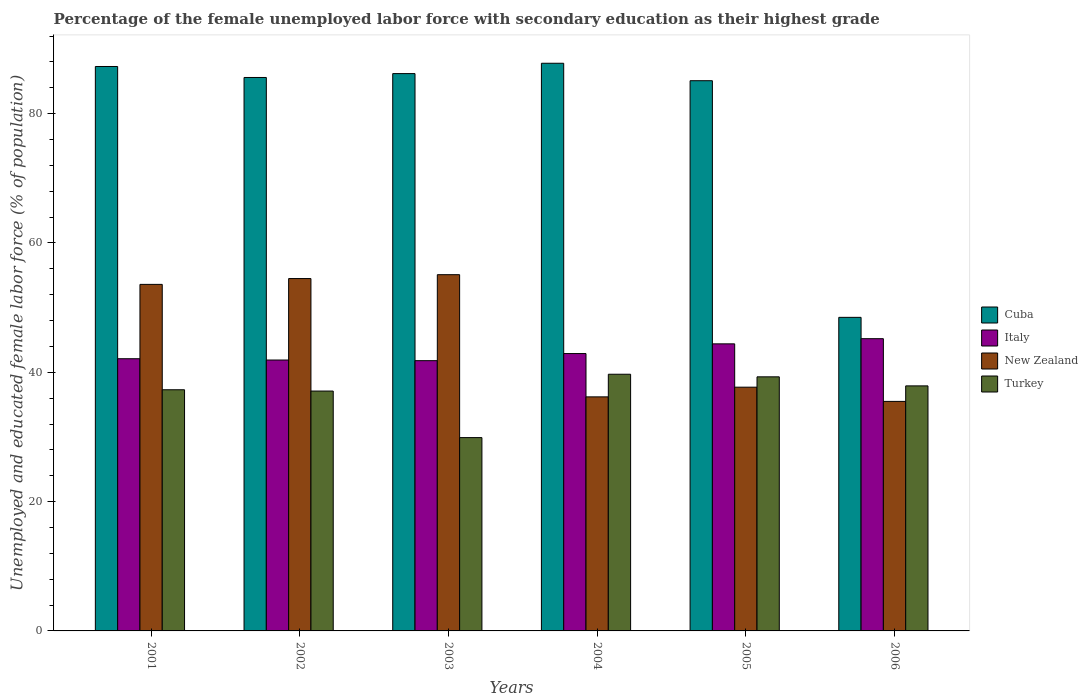How many different coloured bars are there?
Provide a short and direct response. 4. How many groups of bars are there?
Offer a very short reply. 6. Are the number of bars per tick equal to the number of legend labels?
Offer a terse response. Yes. What is the percentage of the unemployed female labor force with secondary education in New Zealand in 2005?
Offer a terse response. 37.7. Across all years, what is the maximum percentage of the unemployed female labor force with secondary education in Italy?
Give a very brief answer. 45.2. Across all years, what is the minimum percentage of the unemployed female labor force with secondary education in Turkey?
Your answer should be very brief. 29.9. In which year was the percentage of the unemployed female labor force with secondary education in Turkey minimum?
Make the answer very short. 2003. What is the total percentage of the unemployed female labor force with secondary education in Italy in the graph?
Offer a very short reply. 258.3. What is the difference between the percentage of the unemployed female labor force with secondary education in New Zealand in 2002 and that in 2004?
Offer a very short reply. 18.3. What is the difference between the percentage of the unemployed female labor force with secondary education in Italy in 2005 and the percentage of the unemployed female labor force with secondary education in Turkey in 2004?
Your response must be concise. 4.7. What is the average percentage of the unemployed female labor force with secondary education in Turkey per year?
Offer a terse response. 36.87. In the year 2004, what is the difference between the percentage of the unemployed female labor force with secondary education in Cuba and percentage of the unemployed female labor force with secondary education in Italy?
Provide a succinct answer. 44.9. What is the ratio of the percentage of the unemployed female labor force with secondary education in Turkey in 2001 to that in 2002?
Your response must be concise. 1.01. Is the percentage of the unemployed female labor force with secondary education in New Zealand in 2002 less than that in 2003?
Give a very brief answer. Yes. Is the difference between the percentage of the unemployed female labor force with secondary education in Cuba in 2002 and 2005 greater than the difference between the percentage of the unemployed female labor force with secondary education in Italy in 2002 and 2005?
Your answer should be very brief. Yes. What is the difference between the highest and the second highest percentage of the unemployed female labor force with secondary education in New Zealand?
Your answer should be compact. 0.6. What is the difference between the highest and the lowest percentage of the unemployed female labor force with secondary education in Cuba?
Provide a short and direct response. 39.3. In how many years, is the percentage of the unemployed female labor force with secondary education in New Zealand greater than the average percentage of the unemployed female labor force with secondary education in New Zealand taken over all years?
Your answer should be very brief. 3. What does the 1st bar from the right in 2006 represents?
Your answer should be very brief. Turkey. How many bars are there?
Make the answer very short. 24. Are all the bars in the graph horizontal?
Make the answer very short. No. Are the values on the major ticks of Y-axis written in scientific E-notation?
Offer a terse response. No. Does the graph contain any zero values?
Make the answer very short. No. Does the graph contain grids?
Your answer should be compact. No. Where does the legend appear in the graph?
Ensure brevity in your answer.  Center right. How many legend labels are there?
Provide a short and direct response. 4. How are the legend labels stacked?
Your answer should be very brief. Vertical. What is the title of the graph?
Your response must be concise. Percentage of the female unemployed labor force with secondary education as their highest grade. What is the label or title of the X-axis?
Offer a very short reply. Years. What is the label or title of the Y-axis?
Keep it short and to the point. Unemployed and educated female labor force (% of population). What is the Unemployed and educated female labor force (% of population) in Cuba in 2001?
Offer a terse response. 87.3. What is the Unemployed and educated female labor force (% of population) of Italy in 2001?
Make the answer very short. 42.1. What is the Unemployed and educated female labor force (% of population) in New Zealand in 2001?
Your answer should be compact. 53.6. What is the Unemployed and educated female labor force (% of population) in Turkey in 2001?
Keep it short and to the point. 37.3. What is the Unemployed and educated female labor force (% of population) of Cuba in 2002?
Your answer should be compact. 85.6. What is the Unemployed and educated female labor force (% of population) in Italy in 2002?
Your answer should be compact. 41.9. What is the Unemployed and educated female labor force (% of population) of New Zealand in 2002?
Offer a very short reply. 54.5. What is the Unemployed and educated female labor force (% of population) in Turkey in 2002?
Your answer should be very brief. 37.1. What is the Unemployed and educated female labor force (% of population) of Cuba in 2003?
Your answer should be very brief. 86.2. What is the Unemployed and educated female labor force (% of population) of Italy in 2003?
Ensure brevity in your answer.  41.8. What is the Unemployed and educated female labor force (% of population) in New Zealand in 2003?
Your response must be concise. 55.1. What is the Unemployed and educated female labor force (% of population) in Turkey in 2003?
Provide a short and direct response. 29.9. What is the Unemployed and educated female labor force (% of population) of Cuba in 2004?
Ensure brevity in your answer.  87.8. What is the Unemployed and educated female labor force (% of population) in Italy in 2004?
Your answer should be very brief. 42.9. What is the Unemployed and educated female labor force (% of population) of New Zealand in 2004?
Provide a succinct answer. 36.2. What is the Unemployed and educated female labor force (% of population) in Turkey in 2004?
Offer a terse response. 39.7. What is the Unemployed and educated female labor force (% of population) in Cuba in 2005?
Your response must be concise. 85.1. What is the Unemployed and educated female labor force (% of population) of Italy in 2005?
Give a very brief answer. 44.4. What is the Unemployed and educated female labor force (% of population) of New Zealand in 2005?
Provide a succinct answer. 37.7. What is the Unemployed and educated female labor force (% of population) of Turkey in 2005?
Provide a succinct answer. 39.3. What is the Unemployed and educated female labor force (% of population) of Cuba in 2006?
Your answer should be compact. 48.5. What is the Unemployed and educated female labor force (% of population) of Italy in 2006?
Provide a short and direct response. 45.2. What is the Unemployed and educated female labor force (% of population) in New Zealand in 2006?
Your answer should be compact. 35.5. What is the Unemployed and educated female labor force (% of population) in Turkey in 2006?
Give a very brief answer. 37.9. Across all years, what is the maximum Unemployed and educated female labor force (% of population) in Cuba?
Offer a very short reply. 87.8. Across all years, what is the maximum Unemployed and educated female labor force (% of population) of Italy?
Your answer should be very brief. 45.2. Across all years, what is the maximum Unemployed and educated female labor force (% of population) in New Zealand?
Your response must be concise. 55.1. Across all years, what is the maximum Unemployed and educated female labor force (% of population) of Turkey?
Your answer should be very brief. 39.7. Across all years, what is the minimum Unemployed and educated female labor force (% of population) in Cuba?
Provide a succinct answer. 48.5. Across all years, what is the minimum Unemployed and educated female labor force (% of population) in Italy?
Ensure brevity in your answer.  41.8. Across all years, what is the minimum Unemployed and educated female labor force (% of population) of New Zealand?
Make the answer very short. 35.5. Across all years, what is the minimum Unemployed and educated female labor force (% of population) of Turkey?
Your response must be concise. 29.9. What is the total Unemployed and educated female labor force (% of population) in Cuba in the graph?
Offer a very short reply. 480.5. What is the total Unemployed and educated female labor force (% of population) in Italy in the graph?
Offer a terse response. 258.3. What is the total Unemployed and educated female labor force (% of population) in New Zealand in the graph?
Give a very brief answer. 272.6. What is the total Unemployed and educated female labor force (% of population) of Turkey in the graph?
Your answer should be very brief. 221.2. What is the difference between the Unemployed and educated female labor force (% of population) of Cuba in 2001 and that in 2002?
Offer a terse response. 1.7. What is the difference between the Unemployed and educated female labor force (% of population) of Italy in 2001 and that in 2002?
Provide a succinct answer. 0.2. What is the difference between the Unemployed and educated female labor force (% of population) of Turkey in 2001 and that in 2002?
Make the answer very short. 0.2. What is the difference between the Unemployed and educated female labor force (% of population) in Italy in 2001 and that in 2003?
Offer a very short reply. 0.3. What is the difference between the Unemployed and educated female labor force (% of population) in New Zealand in 2001 and that in 2003?
Give a very brief answer. -1.5. What is the difference between the Unemployed and educated female labor force (% of population) of Cuba in 2001 and that in 2004?
Keep it short and to the point. -0.5. What is the difference between the Unemployed and educated female labor force (% of population) of New Zealand in 2001 and that in 2005?
Make the answer very short. 15.9. What is the difference between the Unemployed and educated female labor force (% of population) in Turkey in 2001 and that in 2005?
Provide a short and direct response. -2. What is the difference between the Unemployed and educated female labor force (% of population) in Cuba in 2001 and that in 2006?
Provide a short and direct response. 38.8. What is the difference between the Unemployed and educated female labor force (% of population) in New Zealand in 2001 and that in 2006?
Offer a terse response. 18.1. What is the difference between the Unemployed and educated female labor force (% of population) in Turkey in 2001 and that in 2006?
Your answer should be very brief. -0.6. What is the difference between the Unemployed and educated female labor force (% of population) of Cuba in 2002 and that in 2003?
Make the answer very short. -0.6. What is the difference between the Unemployed and educated female labor force (% of population) of Turkey in 2002 and that in 2003?
Your answer should be compact. 7.2. What is the difference between the Unemployed and educated female labor force (% of population) of Italy in 2002 and that in 2004?
Offer a terse response. -1. What is the difference between the Unemployed and educated female labor force (% of population) in Turkey in 2002 and that in 2004?
Keep it short and to the point. -2.6. What is the difference between the Unemployed and educated female labor force (% of population) of Cuba in 2002 and that in 2005?
Offer a very short reply. 0.5. What is the difference between the Unemployed and educated female labor force (% of population) of Italy in 2002 and that in 2005?
Provide a short and direct response. -2.5. What is the difference between the Unemployed and educated female labor force (% of population) of Turkey in 2002 and that in 2005?
Your answer should be compact. -2.2. What is the difference between the Unemployed and educated female labor force (% of population) in Cuba in 2002 and that in 2006?
Provide a succinct answer. 37.1. What is the difference between the Unemployed and educated female labor force (% of population) of Cuba in 2003 and that in 2004?
Give a very brief answer. -1.6. What is the difference between the Unemployed and educated female labor force (% of population) in New Zealand in 2003 and that in 2004?
Make the answer very short. 18.9. What is the difference between the Unemployed and educated female labor force (% of population) of Cuba in 2003 and that in 2005?
Ensure brevity in your answer.  1.1. What is the difference between the Unemployed and educated female labor force (% of population) of Turkey in 2003 and that in 2005?
Your answer should be compact. -9.4. What is the difference between the Unemployed and educated female labor force (% of population) of Cuba in 2003 and that in 2006?
Keep it short and to the point. 37.7. What is the difference between the Unemployed and educated female labor force (% of population) of Italy in 2003 and that in 2006?
Your answer should be very brief. -3.4. What is the difference between the Unemployed and educated female labor force (% of population) in New Zealand in 2003 and that in 2006?
Provide a short and direct response. 19.6. What is the difference between the Unemployed and educated female labor force (% of population) in Turkey in 2003 and that in 2006?
Provide a succinct answer. -8. What is the difference between the Unemployed and educated female labor force (% of population) of Italy in 2004 and that in 2005?
Offer a very short reply. -1.5. What is the difference between the Unemployed and educated female labor force (% of population) of New Zealand in 2004 and that in 2005?
Offer a very short reply. -1.5. What is the difference between the Unemployed and educated female labor force (% of population) in Cuba in 2004 and that in 2006?
Make the answer very short. 39.3. What is the difference between the Unemployed and educated female labor force (% of population) of New Zealand in 2004 and that in 2006?
Provide a short and direct response. 0.7. What is the difference between the Unemployed and educated female labor force (% of population) of Cuba in 2005 and that in 2006?
Make the answer very short. 36.6. What is the difference between the Unemployed and educated female labor force (% of population) of Turkey in 2005 and that in 2006?
Offer a very short reply. 1.4. What is the difference between the Unemployed and educated female labor force (% of population) in Cuba in 2001 and the Unemployed and educated female labor force (% of population) in Italy in 2002?
Ensure brevity in your answer.  45.4. What is the difference between the Unemployed and educated female labor force (% of population) in Cuba in 2001 and the Unemployed and educated female labor force (% of population) in New Zealand in 2002?
Give a very brief answer. 32.8. What is the difference between the Unemployed and educated female labor force (% of population) of Cuba in 2001 and the Unemployed and educated female labor force (% of population) of Turkey in 2002?
Make the answer very short. 50.2. What is the difference between the Unemployed and educated female labor force (% of population) of Italy in 2001 and the Unemployed and educated female labor force (% of population) of New Zealand in 2002?
Provide a short and direct response. -12.4. What is the difference between the Unemployed and educated female labor force (% of population) in New Zealand in 2001 and the Unemployed and educated female labor force (% of population) in Turkey in 2002?
Make the answer very short. 16.5. What is the difference between the Unemployed and educated female labor force (% of population) of Cuba in 2001 and the Unemployed and educated female labor force (% of population) of Italy in 2003?
Make the answer very short. 45.5. What is the difference between the Unemployed and educated female labor force (% of population) in Cuba in 2001 and the Unemployed and educated female labor force (% of population) in New Zealand in 2003?
Offer a terse response. 32.2. What is the difference between the Unemployed and educated female labor force (% of population) in Cuba in 2001 and the Unemployed and educated female labor force (% of population) in Turkey in 2003?
Your response must be concise. 57.4. What is the difference between the Unemployed and educated female labor force (% of population) of New Zealand in 2001 and the Unemployed and educated female labor force (% of population) of Turkey in 2003?
Provide a succinct answer. 23.7. What is the difference between the Unemployed and educated female labor force (% of population) of Cuba in 2001 and the Unemployed and educated female labor force (% of population) of Italy in 2004?
Provide a short and direct response. 44.4. What is the difference between the Unemployed and educated female labor force (% of population) in Cuba in 2001 and the Unemployed and educated female labor force (% of population) in New Zealand in 2004?
Your response must be concise. 51.1. What is the difference between the Unemployed and educated female labor force (% of population) in Cuba in 2001 and the Unemployed and educated female labor force (% of population) in Turkey in 2004?
Your answer should be compact. 47.6. What is the difference between the Unemployed and educated female labor force (% of population) of Italy in 2001 and the Unemployed and educated female labor force (% of population) of New Zealand in 2004?
Provide a short and direct response. 5.9. What is the difference between the Unemployed and educated female labor force (% of population) of Italy in 2001 and the Unemployed and educated female labor force (% of population) of Turkey in 2004?
Offer a terse response. 2.4. What is the difference between the Unemployed and educated female labor force (% of population) of New Zealand in 2001 and the Unemployed and educated female labor force (% of population) of Turkey in 2004?
Ensure brevity in your answer.  13.9. What is the difference between the Unemployed and educated female labor force (% of population) in Cuba in 2001 and the Unemployed and educated female labor force (% of population) in Italy in 2005?
Provide a short and direct response. 42.9. What is the difference between the Unemployed and educated female labor force (% of population) of Cuba in 2001 and the Unemployed and educated female labor force (% of population) of New Zealand in 2005?
Provide a succinct answer. 49.6. What is the difference between the Unemployed and educated female labor force (% of population) in Italy in 2001 and the Unemployed and educated female labor force (% of population) in Turkey in 2005?
Offer a terse response. 2.8. What is the difference between the Unemployed and educated female labor force (% of population) of Cuba in 2001 and the Unemployed and educated female labor force (% of population) of Italy in 2006?
Keep it short and to the point. 42.1. What is the difference between the Unemployed and educated female labor force (% of population) of Cuba in 2001 and the Unemployed and educated female labor force (% of population) of New Zealand in 2006?
Keep it short and to the point. 51.8. What is the difference between the Unemployed and educated female labor force (% of population) of Cuba in 2001 and the Unemployed and educated female labor force (% of population) of Turkey in 2006?
Your answer should be compact. 49.4. What is the difference between the Unemployed and educated female labor force (% of population) in Italy in 2001 and the Unemployed and educated female labor force (% of population) in New Zealand in 2006?
Your answer should be very brief. 6.6. What is the difference between the Unemployed and educated female labor force (% of population) in Italy in 2001 and the Unemployed and educated female labor force (% of population) in Turkey in 2006?
Offer a terse response. 4.2. What is the difference between the Unemployed and educated female labor force (% of population) in New Zealand in 2001 and the Unemployed and educated female labor force (% of population) in Turkey in 2006?
Offer a very short reply. 15.7. What is the difference between the Unemployed and educated female labor force (% of population) in Cuba in 2002 and the Unemployed and educated female labor force (% of population) in Italy in 2003?
Your answer should be compact. 43.8. What is the difference between the Unemployed and educated female labor force (% of population) of Cuba in 2002 and the Unemployed and educated female labor force (% of population) of New Zealand in 2003?
Your answer should be compact. 30.5. What is the difference between the Unemployed and educated female labor force (% of population) in Cuba in 2002 and the Unemployed and educated female labor force (% of population) in Turkey in 2003?
Offer a very short reply. 55.7. What is the difference between the Unemployed and educated female labor force (% of population) of Italy in 2002 and the Unemployed and educated female labor force (% of population) of New Zealand in 2003?
Provide a short and direct response. -13.2. What is the difference between the Unemployed and educated female labor force (% of population) in Italy in 2002 and the Unemployed and educated female labor force (% of population) in Turkey in 2003?
Offer a very short reply. 12. What is the difference between the Unemployed and educated female labor force (% of population) in New Zealand in 2002 and the Unemployed and educated female labor force (% of population) in Turkey in 2003?
Your response must be concise. 24.6. What is the difference between the Unemployed and educated female labor force (% of population) in Cuba in 2002 and the Unemployed and educated female labor force (% of population) in Italy in 2004?
Provide a succinct answer. 42.7. What is the difference between the Unemployed and educated female labor force (% of population) of Cuba in 2002 and the Unemployed and educated female labor force (% of population) of New Zealand in 2004?
Ensure brevity in your answer.  49.4. What is the difference between the Unemployed and educated female labor force (% of population) in Cuba in 2002 and the Unemployed and educated female labor force (% of population) in Turkey in 2004?
Provide a short and direct response. 45.9. What is the difference between the Unemployed and educated female labor force (% of population) in New Zealand in 2002 and the Unemployed and educated female labor force (% of population) in Turkey in 2004?
Your answer should be very brief. 14.8. What is the difference between the Unemployed and educated female labor force (% of population) of Cuba in 2002 and the Unemployed and educated female labor force (% of population) of Italy in 2005?
Your answer should be very brief. 41.2. What is the difference between the Unemployed and educated female labor force (% of population) in Cuba in 2002 and the Unemployed and educated female labor force (% of population) in New Zealand in 2005?
Keep it short and to the point. 47.9. What is the difference between the Unemployed and educated female labor force (% of population) of Cuba in 2002 and the Unemployed and educated female labor force (% of population) of Turkey in 2005?
Your answer should be very brief. 46.3. What is the difference between the Unemployed and educated female labor force (% of population) in Italy in 2002 and the Unemployed and educated female labor force (% of population) in Turkey in 2005?
Your response must be concise. 2.6. What is the difference between the Unemployed and educated female labor force (% of population) in New Zealand in 2002 and the Unemployed and educated female labor force (% of population) in Turkey in 2005?
Ensure brevity in your answer.  15.2. What is the difference between the Unemployed and educated female labor force (% of population) in Cuba in 2002 and the Unemployed and educated female labor force (% of population) in Italy in 2006?
Your answer should be compact. 40.4. What is the difference between the Unemployed and educated female labor force (% of population) in Cuba in 2002 and the Unemployed and educated female labor force (% of population) in New Zealand in 2006?
Ensure brevity in your answer.  50.1. What is the difference between the Unemployed and educated female labor force (% of population) of Cuba in 2002 and the Unemployed and educated female labor force (% of population) of Turkey in 2006?
Provide a succinct answer. 47.7. What is the difference between the Unemployed and educated female labor force (% of population) of Italy in 2002 and the Unemployed and educated female labor force (% of population) of Turkey in 2006?
Your answer should be very brief. 4. What is the difference between the Unemployed and educated female labor force (% of population) in New Zealand in 2002 and the Unemployed and educated female labor force (% of population) in Turkey in 2006?
Your answer should be very brief. 16.6. What is the difference between the Unemployed and educated female labor force (% of population) of Cuba in 2003 and the Unemployed and educated female labor force (% of population) of Italy in 2004?
Offer a very short reply. 43.3. What is the difference between the Unemployed and educated female labor force (% of population) in Cuba in 2003 and the Unemployed and educated female labor force (% of population) in Turkey in 2004?
Provide a short and direct response. 46.5. What is the difference between the Unemployed and educated female labor force (% of population) of Italy in 2003 and the Unemployed and educated female labor force (% of population) of New Zealand in 2004?
Make the answer very short. 5.6. What is the difference between the Unemployed and educated female labor force (% of population) of New Zealand in 2003 and the Unemployed and educated female labor force (% of population) of Turkey in 2004?
Your answer should be very brief. 15.4. What is the difference between the Unemployed and educated female labor force (% of population) of Cuba in 2003 and the Unemployed and educated female labor force (% of population) of Italy in 2005?
Make the answer very short. 41.8. What is the difference between the Unemployed and educated female labor force (% of population) of Cuba in 2003 and the Unemployed and educated female labor force (% of population) of New Zealand in 2005?
Your answer should be compact. 48.5. What is the difference between the Unemployed and educated female labor force (% of population) in Cuba in 2003 and the Unemployed and educated female labor force (% of population) in Turkey in 2005?
Your answer should be compact. 46.9. What is the difference between the Unemployed and educated female labor force (% of population) in Cuba in 2003 and the Unemployed and educated female labor force (% of population) in Italy in 2006?
Your answer should be compact. 41. What is the difference between the Unemployed and educated female labor force (% of population) in Cuba in 2003 and the Unemployed and educated female labor force (% of population) in New Zealand in 2006?
Your response must be concise. 50.7. What is the difference between the Unemployed and educated female labor force (% of population) of Cuba in 2003 and the Unemployed and educated female labor force (% of population) of Turkey in 2006?
Give a very brief answer. 48.3. What is the difference between the Unemployed and educated female labor force (% of population) in Italy in 2003 and the Unemployed and educated female labor force (% of population) in New Zealand in 2006?
Give a very brief answer. 6.3. What is the difference between the Unemployed and educated female labor force (% of population) in Cuba in 2004 and the Unemployed and educated female labor force (% of population) in Italy in 2005?
Your answer should be compact. 43.4. What is the difference between the Unemployed and educated female labor force (% of population) in Cuba in 2004 and the Unemployed and educated female labor force (% of population) in New Zealand in 2005?
Offer a very short reply. 50.1. What is the difference between the Unemployed and educated female labor force (% of population) in Cuba in 2004 and the Unemployed and educated female labor force (% of population) in Turkey in 2005?
Make the answer very short. 48.5. What is the difference between the Unemployed and educated female labor force (% of population) of Italy in 2004 and the Unemployed and educated female labor force (% of population) of New Zealand in 2005?
Give a very brief answer. 5.2. What is the difference between the Unemployed and educated female labor force (% of population) in Italy in 2004 and the Unemployed and educated female labor force (% of population) in Turkey in 2005?
Your answer should be compact. 3.6. What is the difference between the Unemployed and educated female labor force (% of population) in Cuba in 2004 and the Unemployed and educated female labor force (% of population) in Italy in 2006?
Ensure brevity in your answer.  42.6. What is the difference between the Unemployed and educated female labor force (% of population) of Cuba in 2004 and the Unemployed and educated female labor force (% of population) of New Zealand in 2006?
Give a very brief answer. 52.3. What is the difference between the Unemployed and educated female labor force (% of population) of Cuba in 2004 and the Unemployed and educated female labor force (% of population) of Turkey in 2006?
Provide a short and direct response. 49.9. What is the difference between the Unemployed and educated female labor force (% of population) of Italy in 2004 and the Unemployed and educated female labor force (% of population) of New Zealand in 2006?
Offer a terse response. 7.4. What is the difference between the Unemployed and educated female labor force (% of population) of Cuba in 2005 and the Unemployed and educated female labor force (% of population) of Italy in 2006?
Make the answer very short. 39.9. What is the difference between the Unemployed and educated female labor force (% of population) in Cuba in 2005 and the Unemployed and educated female labor force (% of population) in New Zealand in 2006?
Your answer should be very brief. 49.6. What is the difference between the Unemployed and educated female labor force (% of population) of Cuba in 2005 and the Unemployed and educated female labor force (% of population) of Turkey in 2006?
Keep it short and to the point. 47.2. What is the difference between the Unemployed and educated female labor force (% of population) of Italy in 2005 and the Unemployed and educated female labor force (% of population) of New Zealand in 2006?
Offer a terse response. 8.9. What is the average Unemployed and educated female labor force (% of population) in Cuba per year?
Ensure brevity in your answer.  80.08. What is the average Unemployed and educated female labor force (% of population) in Italy per year?
Provide a short and direct response. 43.05. What is the average Unemployed and educated female labor force (% of population) of New Zealand per year?
Offer a terse response. 45.43. What is the average Unemployed and educated female labor force (% of population) in Turkey per year?
Keep it short and to the point. 36.87. In the year 2001, what is the difference between the Unemployed and educated female labor force (% of population) of Cuba and Unemployed and educated female labor force (% of population) of Italy?
Your answer should be very brief. 45.2. In the year 2001, what is the difference between the Unemployed and educated female labor force (% of population) of Cuba and Unemployed and educated female labor force (% of population) of New Zealand?
Offer a very short reply. 33.7. In the year 2001, what is the difference between the Unemployed and educated female labor force (% of population) in Italy and Unemployed and educated female labor force (% of population) in New Zealand?
Provide a short and direct response. -11.5. In the year 2001, what is the difference between the Unemployed and educated female labor force (% of population) in Italy and Unemployed and educated female labor force (% of population) in Turkey?
Offer a terse response. 4.8. In the year 2001, what is the difference between the Unemployed and educated female labor force (% of population) in New Zealand and Unemployed and educated female labor force (% of population) in Turkey?
Ensure brevity in your answer.  16.3. In the year 2002, what is the difference between the Unemployed and educated female labor force (% of population) in Cuba and Unemployed and educated female labor force (% of population) in Italy?
Provide a short and direct response. 43.7. In the year 2002, what is the difference between the Unemployed and educated female labor force (% of population) in Cuba and Unemployed and educated female labor force (% of population) in New Zealand?
Offer a very short reply. 31.1. In the year 2002, what is the difference between the Unemployed and educated female labor force (% of population) in Cuba and Unemployed and educated female labor force (% of population) in Turkey?
Give a very brief answer. 48.5. In the year 2002, what is the difference between the Unemployed and educated female labor force (% of population) of Italy and Unemployed and educated female labor force (% of population) of New Zealand?
Provide a succinct answer. -12.6. In the year 2003, what is the difference between the Unemployed and educated female labor force (% of population) in Cuba and Unemployed and educated female labor force (% of population) in Italy?
Your response must be concise. 44.4. In the year 2003, what is the difference between the Unemployed and educated female labor force (% of population) in Cuba and Unemployed and educated female labor force (% of population) in New Zealand?
Offer a terse response. 31.1. In the year 2003, what is the difference between the Unemployed and educated female labor force (% of population) of Cuba and Unemployed and educated female labor force (% of population) of Turkey?
Keep it short and to the point. 56.3. In the year 2003, what is the difference between the Unemployed and educated female labor force (% of population) in Italy and Unemployed and educated female labor force (% of population) in New Zealand?
Give a very brief answer. -13.3. In the year 2003, what is the difference between the Unemployed and educated female labor force (% of population) of New Zealand and Unemployed and educated female labor force (% of population) of Turkey?
Provide a short and direct response. 25.2. In the year 2004, what is the difference between the Unemployed and educated female labor force (% of population) of Cuba and Unemployed and educated female labor force (% of population) of Italy?
Provide a short and direct response. 44.9. In the year 2004, what is the difference between the Unemployed and educated female labor force (% of population) in Cuba and Unemployed and educated female labor force (% of population) in New Zealand?
Keep it short and to the point. 51.6. In the year 2004, what is the difference between the Unemployed and educated female labor force (% of population) of Cuba and Unemployed and educated female labor force (% of population) of Turkey?
Give a very brief answer. 48.1. In the year 2005, what is the difference between the Unemployed and educated female labor force (% of population) of Cuba and Unemployed and educated female labor force (% of population) of Italy?
Make the answer very short. 40.7. In the year 2005, what is the difference between the Unemployed and educated female labor force (% of population) of Cuba and Unemployed and educated female labor force (% of population) of New Zealand?
Make the answer very short. 47.4. In the year 2005, what is the difference between the Unemployed and educated female labor force (% of population) in Cuba and Unemployed and educated female labor force (% of population) in Turkey?
Offer a very short reply. 45.8. In the year 2005, what is the difference between the Unemployed and educated female labor force (% of population) in Italy and Unemployed and educated female labor force (% of population) in New Zealand?
Offer a terse response. 6.7. In the year 2006, what is the difference between the Unemployed and educated female labor force (% of population) of Cuba and Unemployed and educated female labor force (% of population) of Turkey?
Your response must be concise. 10.6. In the year 2006, what is the difference between the Unemployed and educated female labor force (% of population) of Italy and Unemployed and educated female labor force (% of population) of New Zealand?
Offer a terse response. 9.7. In the year 2006, what is the difference between the Unemployed and educated female labor force (% of population) in Italy and Unemployed and educated female labor force (% of population) in Turkey?
Your answer should be compact. 7.3. In the year 2006, what is the difference between the Unemployed and educated female labor force (% of population) of New Zealand and Unemployed and educated female labor force (% of population) of Turkey?
Your answer should be very brief. -2.4. What is the ratio of the Unemployed and educated female labor force (% of population) in Cuba in 2001 to that in 2002?
Your answer should be compact. 1.02. What is the ratio of the Unemployed and educated female labor force (% of population) of Italy in 2001 to that in 2002?
Your response must be concise. 1. What is the ratio of the Unemployed and educated female labor force (% of population) of New Zealand in 2001 to that in 2002?
Provide a short and direct response. 0.98. What is the ratio of the Unemployed and educated female labor force (% of population) of Turkey in 2001 to that in 2002?
Give a very brief answer. 1.01. What is the ratio of the Unemployed and educated female labor force (% of population) of Cuba in 2001 to that in 2003?
Your answer should be compact. 1.01. What is the ratio of the Unemployed and educated female labor force (% of population) in New Zealand in 2001 to that in 2003?
Offer a very short reply. 0.97. What is the ratio of the Unemployed and educated female labor force (% of population) in Turkey in 2001 to that in 2003?
Your response must be concise. 1.25. What is the ratio of the Unemployed and educated female labor force (% of population) of Cuba in 2001 to that in 2004?
Offer a very short reply. 0.99. What is the ratio of the Unemployed and educated female labor force (% of population) of Italy in 2001 to that in 2004?
Keep it short and to the point. 0.98. What is the ratio of the Unemployed and educated female labor force (% of population) of New Zealand in 2001 to that in 2004?
Make the answer very short. 1.48. What is the ratio of the Unemployed and educated female labor force (% of population) of Turkey in 2001 to that in 2004?
Provide a succinct answer. 0.94. What is the ratio of the Unemployed and educated female labor force (% of population) in Cuba in 2001 to that in 2005?
Keep it short and to the point. 1.03. What is the ratio of the Unemployed and educated female labor force (% of population) of Italy in 2001 to that in 2005?
Provide a succinct answer. 0.95. What is the ratio of the Unemployed and educated female labor force (% of population) in New Zealand in 2001 to that in 2005?
Offer a terse response. 1.42. What is the ratio of the Unemployed and educated female labor force (% of population) of Turkey in 2001 to that in 2005?
Ensure brevity in your answer.  0.95. What is the ratio of the Unemployed and educated female labor force (% of population) of Italy in 2001 to that in 2006?
Your answer should be very brief. 0.93. What is the ratio of the Unemployed and educated female labor force (% of population) in New Zealand in 2001 to that in 2006?
Make the answer very short. 1.51. What is the ratio of the Unemployed and educated female labor force (% of population) of Turkey in 2001 to that in 2006?
Your answer should be very brief. 0.98. What is the ratio of the Unemployed and educated female labor force (% of population) of Italy in 2002 to that in 2003?
Your answer should be very brief. 1. What is the ratio of the Unemployed and educated female labor force (% of population) in New Zealand in 2002 to that in 2003?
Offer a very short reply. 0.99. What is the ratio of the Unemployed and educated female labor force (% of population) in Turkey in 2002 to that in 2003?
Offer a terse response. 1.24. What is the ratio of the Unemployed and educated female labor force (% of population) of Cuba in 2002 to that in 2004?
Offer a very short reply. 0.97. What is the ratio of the Unemployed and educated female labor force (% of population) of Italy in 2002 to that in 2004?
Ensure brevity in your answer.  0.98. What is the ratio of the Unemployed and educated female labor force (% of population) of New Zealand in 2002 to that in 2004?
Provide a short and direct response. 1.51. What is the ratio of the Unemployed and educated female labor force (% of population) of Turkey in 2002 to that in 2004?
Provide a succinct answer. 0.93. What is the ratio of the Unemployed and educated female labor force (% of population) in Cuba in 2002 to that in 2005?
Provide a short and direct response. 1.01. What is the ratio of the Unemployed and educated female labor force (% of population) in Italy in 2002 to that in 2005?
Your answer should be compact. 0.94. What is the ratio of the Unemployed and educated female labor force (% of population) in New Zealand in 2002 to that in 2005?
Provide a short and direct response. 1.45. What is the ratio of the Unemployed and educated female labor force (% of population) in Turkey in 2002 to that in 2005?
Offer a terse response. 0.94. What is the ratio of the Unemployed and educated female labor force (% of population) in Cuba in 2002 to that in 2006?
Give a very brief answer. 1.76. What is the ratio of the Unemployed and educated female labor force (% of population) in Italy in 2002 to that in 2006?
Keep it short and to the point. 0.93. What is the ratio of the Unemployed and educated female labor force (% of population) in New Zealand in 2002 to that in 2006?
Your answer should be very brief. 1.54. What is the ratio of the Unemployed and educated female labor force (% of population) in Turkey in 2002 to that in 2006?
Provide a succinct answer. 0.98. What is the ratio of the Unemployed and educated female labor force (% of population) of Cuba in 2003 to that in 2004?
Give a very brief answer. 0.98. What is the ratio of the Unemployed and educated female labor force (% of population) of Italy in 2003 to that in 2004?
Give a very brief answer. 0.97. What is the ratio of the Unemployed and educated female labor force (% of population) in New Zealand in 2003 to that in 2004?
Provide a short and direct response. 1.52. What is the ratio of the Unemployed and educated female labor force (% of population) of Turkey in 2003 to that in 2004?
Offer a very short reply. 0.75. What is the ratio of the Unemployed and educated female labor force (% of population) of Cuba in 2003 to that in 2005?
Keep it short and to the point. 1.01. What is the ratio of the Unemployed and educated female labor force (% of population) in Italy in 2003 to that in 2005?
Make the answer very short. 0.94. What is the ratio of the Unemployed and educated female labor force (% of population) of New Zealand in 2003 to that in 2005?
Ensure brevity in your answer.  1.46. What is the ratio of the Unemployed and educated female labor force (% of population) of Turkey in 2003 to that in 2005?
Make the answer very short. 0.76. What is the ratio of the Unemployed and educated female labor force (% of population) in Cuba in 2003 to that in 2006?
Provide a short and direct response. 1.78. What is the ratio of the Unemployed and educated female labor force (% of population) of Italy in 2003 to that in 2006?
Offer a very short reply. 0.92. What is the ratio of the Unemployed and educated female labor force (% of population) in New Zealand in 2003 to that in 2006?
Your answer should be very brief. 1.55. What is the ratio of the Unemployed and educated female labor force (% of population) in Turkey in 2003 to that in 2006?
Your response must be concise. 0.79. What is the ratio of the Unemployed and educated female labor force (% of population) of Cuba in 2004 to that in 2005?
Give a very brief answer. 1.03. What is the ratio of the Unemployed and educated female labor force (% of population) in Italy in 2004 to that in 2005?
Your response must be concise. 0.97. What is the ratio of the Unemployed and educated female labor force (% of population) in New Zealand in 2004 to that in 2005?
Provide a succinct answer. 0.96. What is the ratio of the Unemployed and educated female labor force (% of population) of Turkey in 2004 to that in 2005?
Provide a succinct answer. 1.01. What is the ratio of the Unemployed and educated female labor force (% of population) in Cuba in 2004 to that in 2006?
Make the answer very short. 1.81. What is the ratio of the Unemployed and educated female labor force (% of population) of Italy in 2004 to that in 2006?
Ensure brevity in your answer.  0.95. What is the ratio of the Unemployed and educated female labor force (% of population) of New Zealand in 2004 to that in 2006?
Offer a very short reply. 1.02. What is the ratio of the Unemployed and educated female labor force (% of population) in Turkey in 2004 to that in 2006?
Give a very brief answer. 1.05. What is the ratio of the Unemployed and educated female labor force (% of population) in Cuba in 2005 to that in 2006?
Your answer should be very brief. 1.75. What is the ratio of the Unemployed and educated female labor force (% of population) of Italy in 2005 to that in 2006?
Your answer should be very brief. 0.98. What is the ratio of the Unemployed and educated female labor force (% of population) in New Zealand in 2005 to that in 2006?
Your answer should be very brief. 1.06. What is the ratio of the Unemployed and educated female labor force (% of population) in Turkey in 2005 to that in 2006?
Make the answer very short. 1.04. What is the difference between the highest and the second highest Unemployed and educated female labor force (% of population) of New Zealand?
Ensure brevity in your answer.  0.6. What is the difference between the highest and the second highest Unemployed and educated female labor force (% of population) in Turkey?
Give a very brief answer. 0.4. What is the difference between the highest and the lowest Unemployed and educated female labor force (% of population) of Cuba?
Your answer should be compact. 39.3. What is the difference between the highest and the lowest Unemployed and educated female labor force (% of population) of New Zealand?
Ensure brevity in your answer.  19.6. What is the difference between the highest and the lowest Unemployed and educated female labor force (% of population) of Turkey?
Provide a short and direct response. 9.8. 